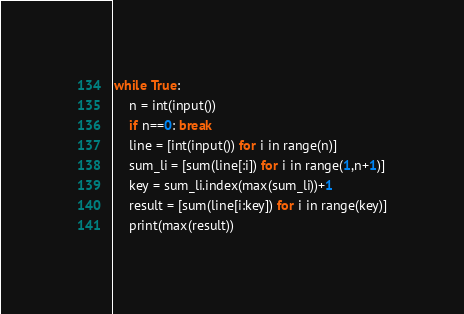Convert code to text. <code><loc_0><loc_0><loc_500><loc_500><_Python_>while True:
    n = int(input())
    if n==0: break
    line = [int(input()) for i in range(n)]
    sum_li = [sum(line[:i]) for i in range(1,n+1)]
    key = sum_li.index(max(sum_li))+1
    result = [sum(line[i:key]) for i in range(key)]
    print(max(result))</code> 